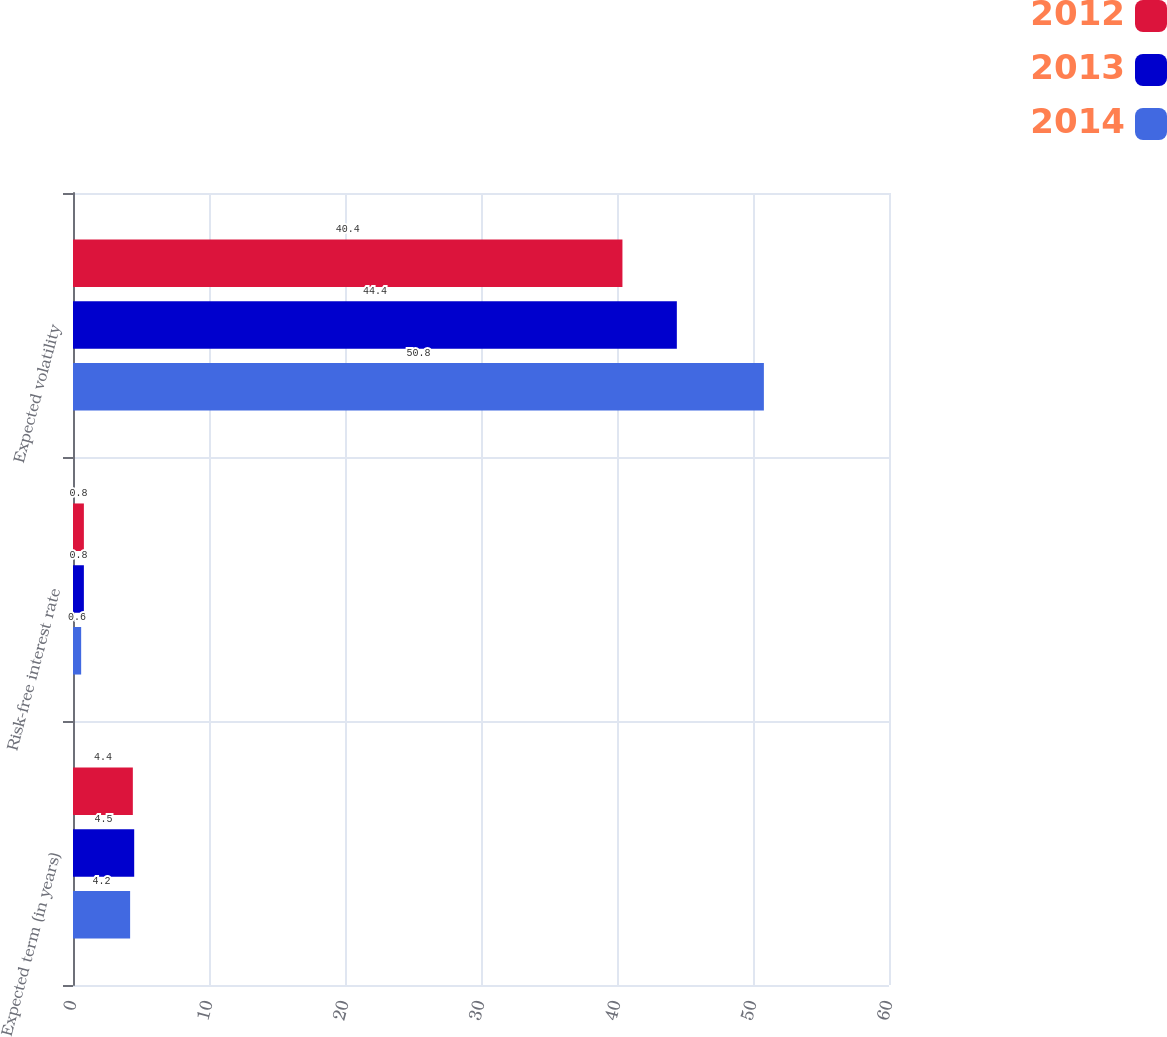Convert chart. <chart><loc_0><loc_0><loc_500><loc_500><stacked_bar_chart><ecel><fcel>Expected term (in years)<fcel>Risk-free interest rate<fcel>Expected volatility<nl><fcel>2012<fcel>4.4<fcel>0.8<fcel>40.4<nl><fcel>2013<fcel>4.5<fcel>0.8<fcel>44.4<nl><fcel>2014<fcel>4.2<fcel>0.6<fcel>50.8<nl></chart> 